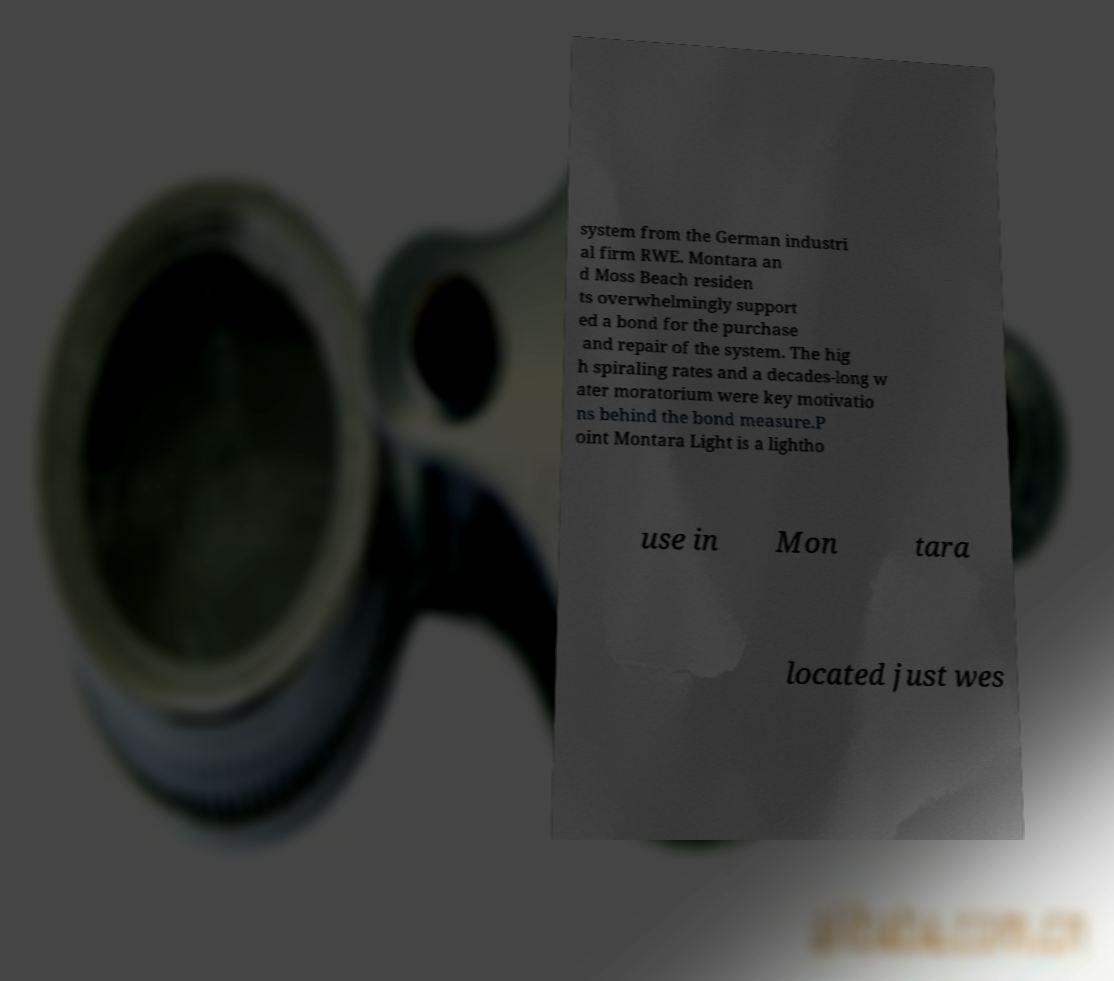I need the written content from this picture converted into text. Can you do that? system from the German industri al firm RWE. Montara an d Moss Beach residen ts overwhelmingly support ed a bond for the purchase and repair of the system. The hig h spiraling rates and a decades-long w ater moratorium were key motivatio ns behind the bond measure.P oint Montara Light is a lightho use in Mon tara located just wes 